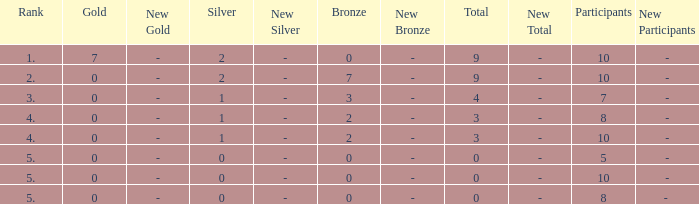What's the total Rank that has a Gold that's smaller than 0? None. 